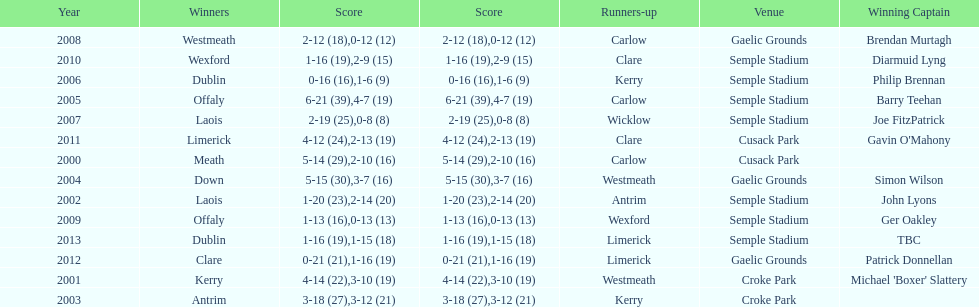Who scored the least? Wicklow. 